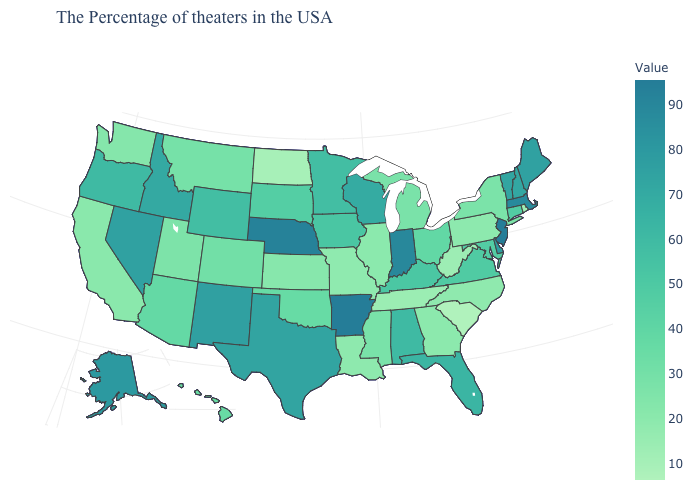Which states have the highest value in the USA?
Give a very brief answer. Arkansas. Among the states that border Idaho , which have the highest value?
Write a very short answer. Nevada. Which states have the lowest value in the USA?
Give a very brief answer. South Carolina. Does Arkansas have the highest value in the USA?
Concise answer only. Yes. Among the states that border Kansas , does Oklahoma have the lowest value?
Answer briefly. No. Does the map have missing data?
Give a very brief answer. No. Which states have the highest value in the USA?
Short answer required. Arkansas. 